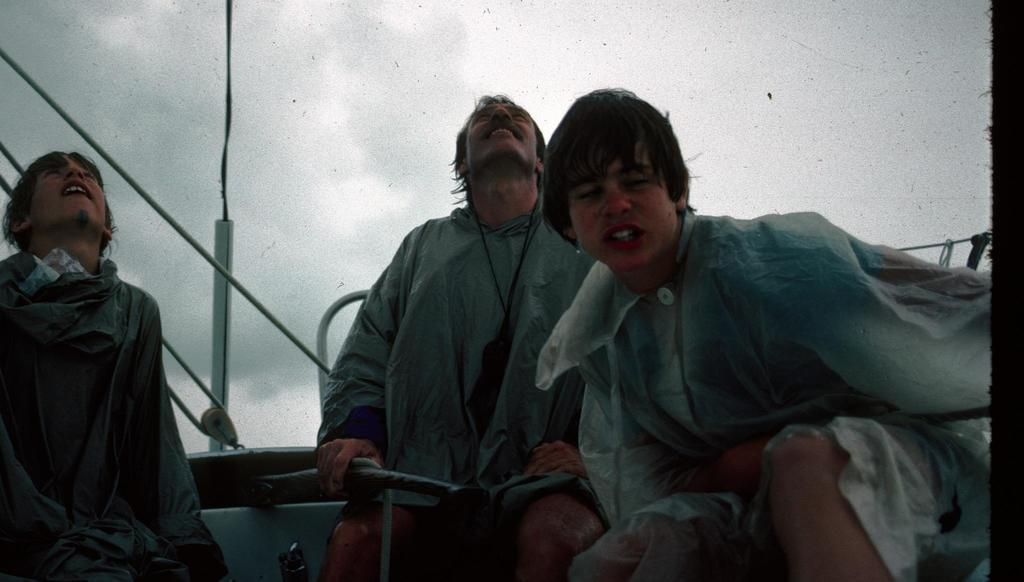What are the people in the image doing? The people in the image are sitting. What can be seen in the background of the image? There are ropes and the sky visible in the background of the image. What type of amusement can be seen in the image involving a squirrel and a cook? There is no amusement, squirrel, or cook present in the image. 